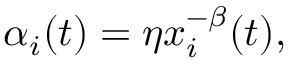Convert formula to latex. <formula><loc_0><loc_0><loc_500><loc_500>\begin{array} { r } { \alpha _ { i } ( t ) = \eta x _ { i } ^ { - \beta } ( t ) , } \end{array}</formula> 